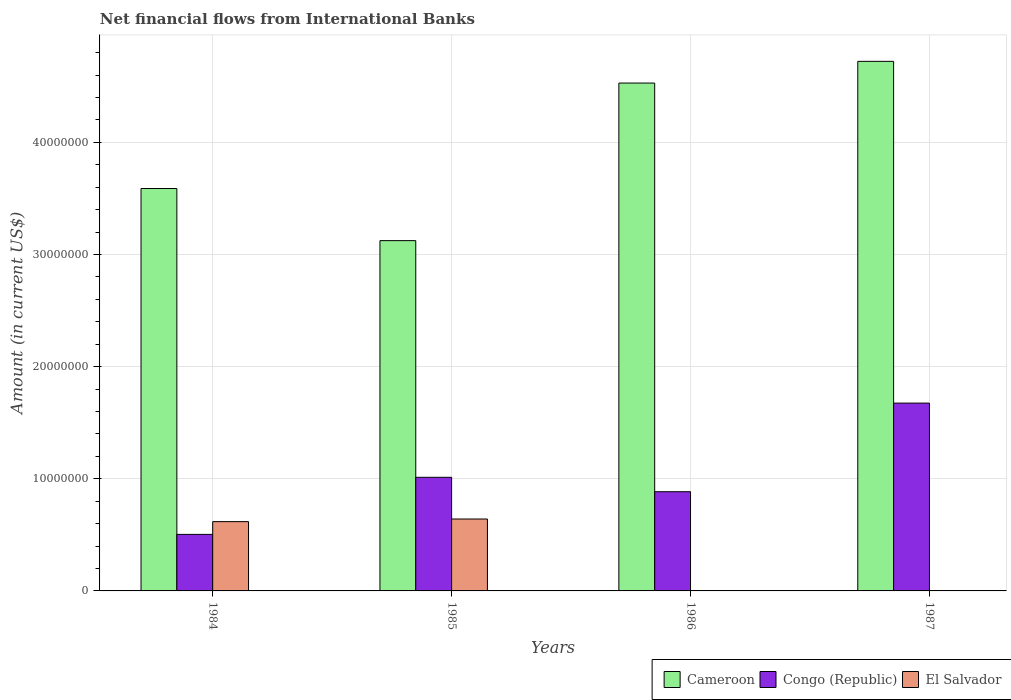Are the number of bars per tick equal to the number of legend labels?
Ensure brevity in your answer.  No. Are the number of bars on each tick of the X-axis equal?
Offer a terse response. No. How many bars are there on the 1st tick from the left?
Offer a terse response. 3. How many bars are there on the 1st tick from the right?
Offer a terse response. 2. What is the label of the 1st group of bars from the left?
Keep it short and to the point. 1984. What is the net financial aid flows in Congo (Republic) in 1987?
Give a very brief answer. 1.68e+07. Across all years, what is the maximum net financial aid flows in Congo (Republic)?
Keep it short and to the point. 1.68e+07. Across all years, what is the minimum net financial aid flows in El Salvador?
Ensure brevity in your answer.  0. What is the total net financial aid flows in El Salvador in the graph?
Your response must be concise. 1.26e+07. What is the difference between the net financial aid flows in Congo (Republic) in 1984 and that in 1986?
Provide a short and direct response. -3.81e+06. What is the difference between the net financial aid flows in Congo (Republic) in 1987 and the net financial aid flows in Cameroon in 1985?
Your answer should be compact. -1.45e+07. What is the average net financial aid flows in Cameroon per year?
Offer a terse response. 3.99e+07. In the year 1985, what is the difference between the net financial aid flows in El Salvador and net financial aid flows in Congo (Republic)?
Make the answer very short. -3.72e+06. What is the ratio of the net financial aid flows in Cameroon in 1984 to that in 1987?
Offer a very short reply. 0.76. Is the net financial aid flows in Cameroon in 1984 less than that in 1987?
Your answer should be very brief. Yes. Is the difference between the net financial aid flows in El Salvador in 1984 and 1985 greater than the difference between the net financial aid flows in Congo (Republic) in 1984 and 1985?
Make the answer very short. Yes. What is the difference between the highest and the second highest net financial aid flows in Congo (Republic)?
Your answer should be compact. 6.62e+06. What is the difference between the highest and the lowest net financial aid flows in El Salvador?
Give a very brief answer. 6.41e+06. In how many years, is the net financial aid flows in Congo (Republic) greater than the average net financial aid flows in Congo (Republic) taken over all years?
Give a very brief answer. 1. Is the sum of the net financial aid flows in Congo (Republic) in 1985 and 1987 greater than the maximum net financial aid flows in Cameroon across all years?
Offer a terse response. No. Is it the case that in every year, the sum of the net financial aid flows in El Salvador and net financial aid flows in Congo (Republic) is greater than the net financial aid flows in Cameroon?
Your response must be concise. No. Does the graph contain any zero values?
Provide a short and direct response. Yes. Where does the legend appear in the graph?
Provide a succinct answer. Bottom right. How many legend labels are there?
Make the answer very short. 3. What is the title of the graph?
Make the answer very short. Net financial flows from International Banks. What is the label or title of the X-axis?
Your response must be concise. Years. What is the Amount (in current US$) in Cameroon in 1984?
Offer a terse response. 3.59e+07. What is the Amount (in current US$) of Congo (Republic) in 1984?
Offer a very short reply. 5.04e+06. What is the Amount (in current US$) in El Salvador in 1984?
Ensure brevity in your answer.  6.18e+06. What is the Amount (in current US$) of Cameroon in 1985?
Your answer should be very brief. 3.12e+07. What is the Amount (in current US$) in Congo (Republic) in 1985?
Your answer should be compact. 1.01e+07. What is the Amount (in current US$) of El Salvador in 1985?
Ensure brevity in your answer.  6.41e+06. What is the Amount (in current US$) of Cameroon in 1986?
Your response must be concise. 4.53e+07. What is the Amount (in current US$) in Congo (Republic) in 1986?
Keep it short and to the point. 8.85e+06. What is the Amount (in current US$) in El Salvador in 1986?
Keep it short and to the point. 0. What is the Amount (in current US$) of Cameroon in 1987?
Your response must be concise. 4.72e+07. What is the Amount (in current US$) of Congo (Republic) in 1987?
Your answer should be very brief. 1.68e+07. Across all years, what is the maximum Amount (in current US$) in Cameroon?
Ensure brevity in your answer.  4.72e+07. Across all years, what is the maximum Amount (in current US$) in Congo (Republic)?
Give a very brief answer. 1.68e+07. Across all years, what is the maximum Amount (in current US$) of El Salvador?
Offer a terse response. 6.41e+06. Across all years, what is the minimum Amount (in current US$) of Cameroon?
Your answer should be very brief. 3.12e+07. Across all years, what is the minimum Amount (in current US$) in Congo (Republic)?
Offer a terse response. 5.04e+06. Across all years, what is the minimum Amount (in current US$) of El Salvador?
Offer a very short reply. 0. What is the total Amount (in current US$) in Cameroon in the graph?
Keep it short and to the point. 1.60e+08. What is the total Amount (in current US$) of Congo (Republic) in the graph?
Your answer should be very brief. 4.08e+07. What is the total Amount (in current US$) in El Salvador in the graph?
Offer a terse response. 1.26e+07. What is the difference between the Amount (in current US$) in Cameroon in 1984 and that in 1985?
Your response must be concise. 4.65e+06. What is the difference between the Amount (in current US$) in Congo (Republic) in 1984 and that in 1985?
Your answer should be compact. -5.09e+06. What is the difference between the Amount (in current US$) of El Salvador in 1984 and that in 1985?
Provide a short and direct response. -2.33e+05. What is the difference between the Amount (in current US$) in Cameroon in 1984 and that in 1986?
Provide a short and direct response. -9.40e+06. What is the difference between the Amount (in current US$) of Congo (Republic) in 1984 and that in 1986?
Offer a terse response. -3.81e+06. What is the difference between the Amount (in current US$) of Cameroon in 1984 and that in 1987?
Keep it short and to the point. -1.13e+07. What is the difference between the Amount (in current US$) of Congo (Republic) in 1984 and that in 1987?
Offer a terse response. -1.17e+07. What is the difference between the Amount (in current US$) in Cameroon in 1985 and that in 1986?
Keep it short and to the point. -1.41e+07. What is the difference between the Amount (in current US$) in Congo (Republic) in 1985 and that in 1986?
Offer a very short reply. 1.28e+06. What is the difference between the Amount (in current US$) in Cameroon in 1985 and that in 1987?
Offer a very short reply. -1.60e+07. What is the difference between the Amount (in current US$) of Congo (Republic) in 1985 and that in 1987?
Make the answer very short. -6.62e+06. What is the difference between the Amount (in current US$) in Cameroon in 1986 and that in 1987?
Give a very brief answer. -1.94e+06. What is the difference between the Amount (in current US$) of Congo (Republic) in 1986 and that in 1987?
Your answer should be compact. -7.90e+06. What is the difference between the Amount (in current US$) of Cameroon in 1984 and the Amount (in current US$) of Congo (Republic) in 1985?
Keep it short and to the point. 2.58e+07. What is the difference between the Amount (in current US$) in Cameroon in 1984 and the Amount (in current US$) in El Salvador in 1985?
Your response must be concise. 2.95e+07. What is the difference between the Amount (in current US$) of Congo (Republic) in 1984 and the Amount (in current US$) of El Salvador in 1985?
Offer a terse response. -1.37e+06. What is the difference between the Amount (in current US$) of Cameroon in 1984 and the Amount (in current US$) of Congo (Republic) in 1986?
Keep it short and to the point. 2.70e+07. What is the difference between the Amount (in current US$) in Cameroon in 1984 and the Amount (in current US$) in Congo (Republic) in 1987?
Keep it short and to the point. 1.91e+07. What is the difference between the Amount (in current US$) in Cameroon in 1985 and the Amount (in current US$) in Congo (Republic) in 1986?
Provide a short and direct response. 2.24e+07. What is the difference between the Amount (in current US$) in Cameroon in 1985 and the Amount (in current US$) in Congo (Republic) in 1987?
Your response must be concise. 1.45e+07. What is the difference between the Amount (in current US$) in Cameroon in 1986 and the Amount (in current US$) in Congo (Republic) in 1987?
Your answer should be compact. 2.85e+07. What is the average Amount (in current US$) in Cameroon per year?
Provide a short and direct response. 3.99e+07. What is the average Amount (in current US$) in Congo (Republic) per year?
Your response must be concise. 1.02e+07. What is the average Amount (in current US$) of El Salvador per year?
Your answer should be very brief. 3.15e+06. In the year 1984, what is the difference between the Amount (in current US$) in Cameroon and Amount (in current US$) in Congo (Republic)?
Make the answer very short. 3.08e+07. In the year 1984, what is the difference between the Amount (in current US$) in Cameroon and Amount (in current US$) in El Salvador?
Make the answer very short. 2.97e+07. In the year 1984, what is the difference between the Amount (in current US$) in Congo (Republic) and Amount (in current US$) in El Salvador?
Give a very brief answer. -1.14e+06. In the year 1985, what is the difference between the Amount (in current US$) in Cameroon and Amount (in current US$) in Congo (Republic)?
Provide a succinct answer. 2.11e+07. In the year 1985, what is the difference between the Amount (in current US$) of Cameroon and Amount (in current US$) of El Salvador?
Your response must be concise. 2.48e+07. In the year 1985, what is the difference between the Amount (in current US$) of Congo (Republic) and Amount (in current US$) of El Salvador?
Your answer should be very brief. 3.72e+06. In the year 1986, what is the difference between the Amount (in current US$) of Cameroon and Amount (in current US$) of Congo (Republic)?
Offer a terse response. 3.64e+07. In the year 1987, what is the difference between the Amount (in current US$) in Cameroon and Amount (in current US$) in Congo (Republic)?
Ensure brevity in your answer.  3.05e+07. What is the ratio of the Amount (in current US$) in Cameroon in 1984 to that in 1985?
Ensure brevity in your answer.  1.15. What is the ratio of the Amount (in current US$) of Congo (Republic) in 1984 to that in 1985?
Provide a short and direct response. 0.5. What is the ratio of the Amount (in current US$) of El Salvador in 1984 to that in 1985?
Make the answer very short. 0.96. What is the ratio of the Amount (in current US$) of Cameroon in 1984 to that in 1986?
Ensure brevity in your answer.  0.79. What is the ratio of the Amount (in current US$) in Congo (Republic) in 1984 to that in 1986?
Keep it short and to the point. 0.57. What is the ratio of the Amount (in current US$) in Cameroon in 1984 to that in 1987?
Provide a succinct answer. 0.76. What is the ratio of the Amount (in current US$) of Congo (Republic) in 1984 to that in 1987?
Ensure brevity in your answer.  0.3. What is the ratio of the Amount (in current US$) of Cameroon in 1985 to that in 1986?
Your answer should be compact. 0.69. What is the ratio of the Amount (in current US$) of Congo (Republic) in 1985 to that in 1986?
Provide a succinct answer. 1.15. What is the ratio of the Amount (in current US$) of Cameroon in 1985 to that in 1987?
Your answer should be compact. 0.66. What is the ratio of the Amount (in current US$) in Congo (Republic) in 1985 to that in 1987?
Provide a succinct answer. 0.6. What is the ratio of the Amount (in current US$) in Congo (Republic) in 1986 to that in 1987?
Give a very brief answer. 0.53. What is the difference between the highest and the second highest Amount (in current US$) of Cameroon?
Provide a succinct answer. 1.94e+06. What is the difference between the highest and the second highest Amount (in current US$) of Congo (Republic)?
Provide a succinct answer. 6.62e+06. What is the difference between the highest and the lowest Amount (in current US$) of Cameroon?
Provide a short and direct response. 1.60e+07. What is the difference between the highest and the lowest Amount (in current US$) of Congo (Republic)?
Keep it short and to the point. 1.17e+07. What is the difference between the highest and the lowest Amount (in current US$) of El Salvador?
Give a very brief answer. 6.41e+06. 